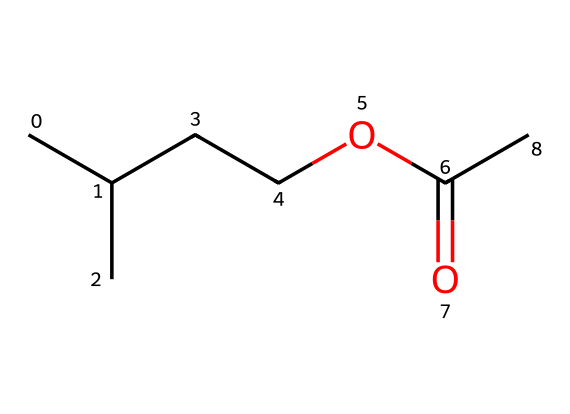What is the molecular formula of isoamyl acetate? To find the molecular formula, count the number of carbons, hydrogens, and oxygens in the provided SMILES representation. The SMILES shows 5 carbons (C), 10 hydrogens (H), and 2 oxygens (O), leading to the formula C5H10O2.
Answer: C5H10O2 How many carbon atoms are present in isoamyl acetate? By analyzing the SMILES representation, there are five carbon atoms visible in the main carbon chain and branches.
Answer: 5 What type of functional group is characteristic of isoamyl acetate? The presence of the ester group, identified by the -COO- bridge, indicates that this molecule is an ester, which is defined by the interaction between a carboxylic acid and an alcohol.
Answer: ester What is the common scent associated with isoamyl acetate? Isoamyl acetate is known for its banana scent, commonly used in perfumes and flavorings, which can be identified by its structure and functional group.
Answer: banana How many total atoms are present in isoamyl acetate? To calculate the total number of atoms, add the counts of carbon (5), hydrogen (10), and oxygen (2): 5 + 10 + 2 = 17 total atoms.
Answer: 17 What is the significance of the acetyl group in isoamyl acetate's structure? The acetyl group (part of the ester functional group) contributes to the characteristic properties of the compound, including its scent and volatility. The presence of this group is essential for identifying it as an ester.
Answer: acetyl group 